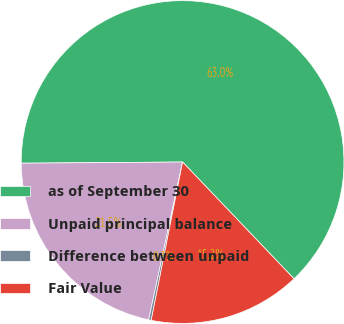Convert chart to OTSL. <chart><loc_0><loc_0><loc_500><loc_500><pie_chart><fcel>as of September 30<fcel>Unpaid principal balance<fcel>Difference between unpaid<fcel>Fair Value<nl><fcel>62.99%<fcel>21.51%<fcel>0.26%<fcel>15.24%<nl></chart> 